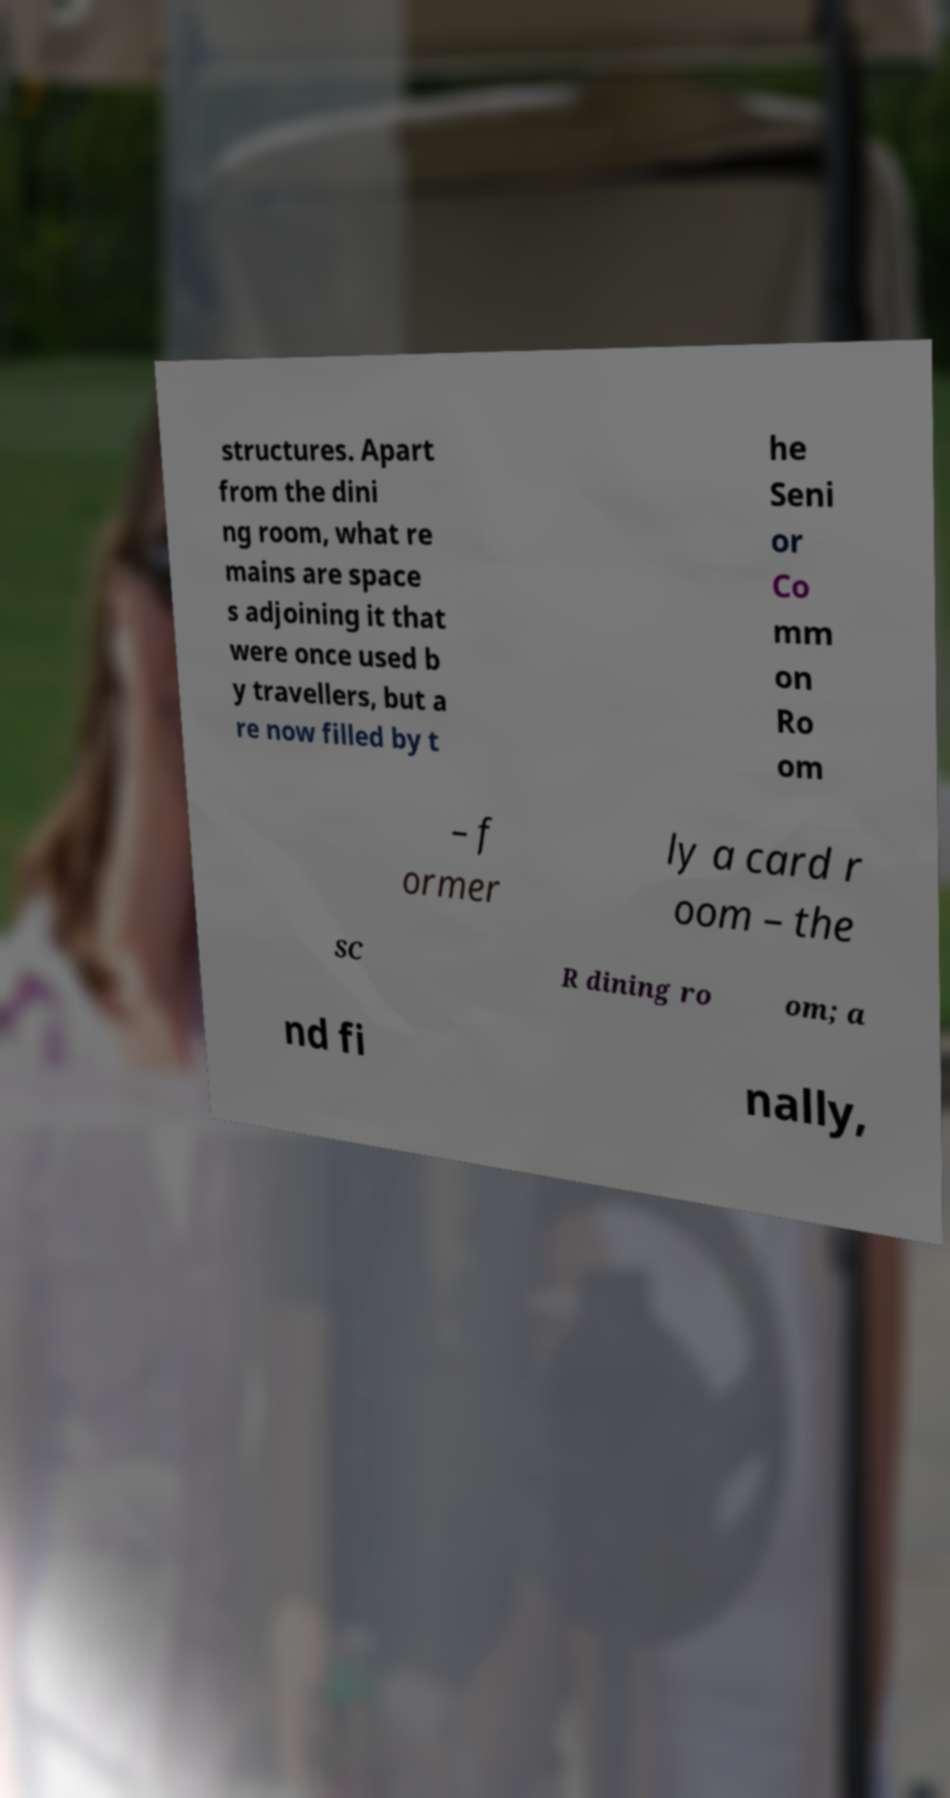For documentation purposes, I need the text within this image transcribed. Could you provide that? structures. Apart from the dini ng room, what re mains are space s adjoining it that were once used b y travellers, but a re now filled by t he Seni or Co mm on Ro om – f ormer ly a card r oom – the SC R dining ro om; a nd fi nally, 